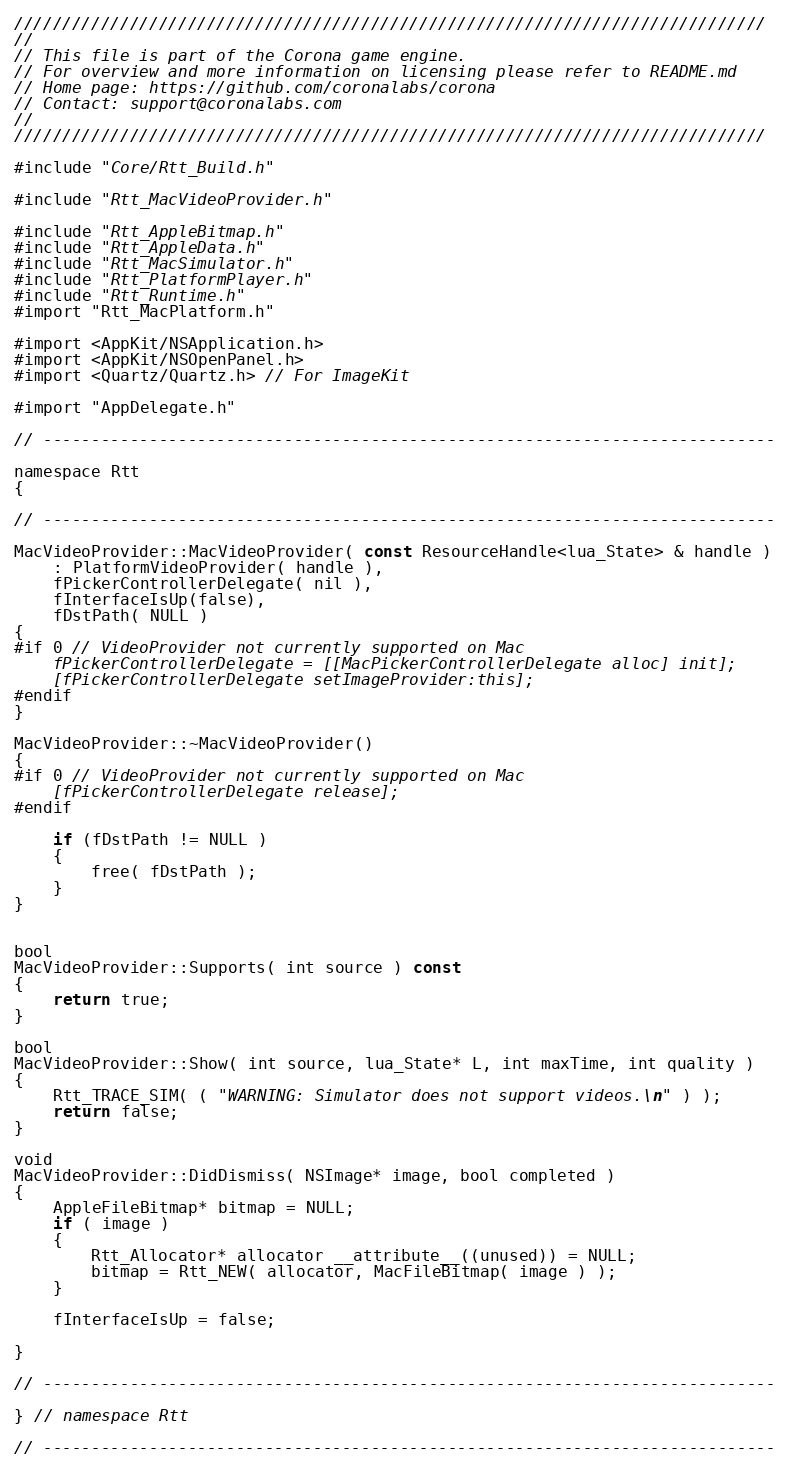<code> <loc_0><loc_0><loc_500><loc_500><_ObjectiveC_>//////////////////////////////////////////////////////////////////////////////
//
// This file is part of the Corona game engine.
// For overview and more information on licensing please refer to README.md 
// Home page: https://github.com/coronalabs/corona
// Contact: support@coronalabs.com
//
//////////////////////////////////////////////////////////////////////////////

#include "Core/Rtt_Build.h"

#include "Rtt_MacVideoProvider.h"

#include "Rtt_AppleBitmap.h"
#include "Rtt_AppleData.h"
#include "Rtt_MacSimulator.h"
#include "Rtt_PlatformPlayer.h"
#include "Rtt_Runtime.h"
#import "Rtt_MacPlatform.h"

#import <AppKit/NSApplication.h>
#import <AppKit/NSOpenPanel.h>
#import <Quartz/Quartz.h> // For ImageKit

#import "AppDelegate.h"

// ----------------------------------------------------------------------------

namespace Rtt
{

// ----------------------------------------------------------------------------
	
MacVideoProvider::MacVideoProvider( const ResourceHandle<lua_State> & handle ) 
	: PlatformVideoProvider( handle ),
	fPickerControllerDelegate( nil ),
	fInterfaceIsUp(false),
	fDstPath( NULL )
{
#if 0 // VideoProvider not currently supported on Mac
	fPickerControllerDelegate = [[MacPickerControllerDelegate alloc] init];
	[fPickerControllerDelegate setImageProvider:this];
#endif
}

MacVideoProvider::~MacVideoProvider()
{
#if 0 // VideoProvider not currently supported on Mac
	[fPickerControllerDelegate release];
#endif
    
    if (fDstPath != NULL )
    {
        free( fDstPath );
    }
}

	
bool
MacVideoProvider::Supports( int source ) const
{
	return true;
}

bool
MacVideoProvider::Show( int source, lua_State* L, int maxTime, int quality )
{
	Rtt_TRACE_SIM( ( "WARNING: Simulator does not support videos.\n" ) );
	return false;
}
	
void
MacVideoProvider::DidDismiss( NSImage* image, bool completed )
{
	AppleFileBitmap* bitmap = NULL;
	if ( image )
	{	
		Rtt_Allocator* allocator __attribute__((unused)) = NULL;
		bitmap = Rtt_NEW( allocator, MacFileBitmap( image ) );
	}

	fInterfaceIsUp = false;

}

// ----------------------------------------------------------------------------

} // namespace Rtt

// ----------------------------------------------------------------------------

</code> 